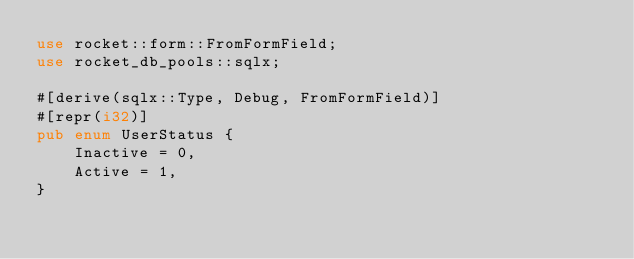Convert code to text. <code><loc_0><loc_0><loc_500><loc_500><_Rust_>use rocket::form::FromFormField;
use rocket_db_pools::sqlx;

#[derive(sqlx::Type, Debug, FromFormField)]
#[repr(i32)]
pub enum UserStatus {
    Inactive = 0,
    Active = 1,
}
</code> 